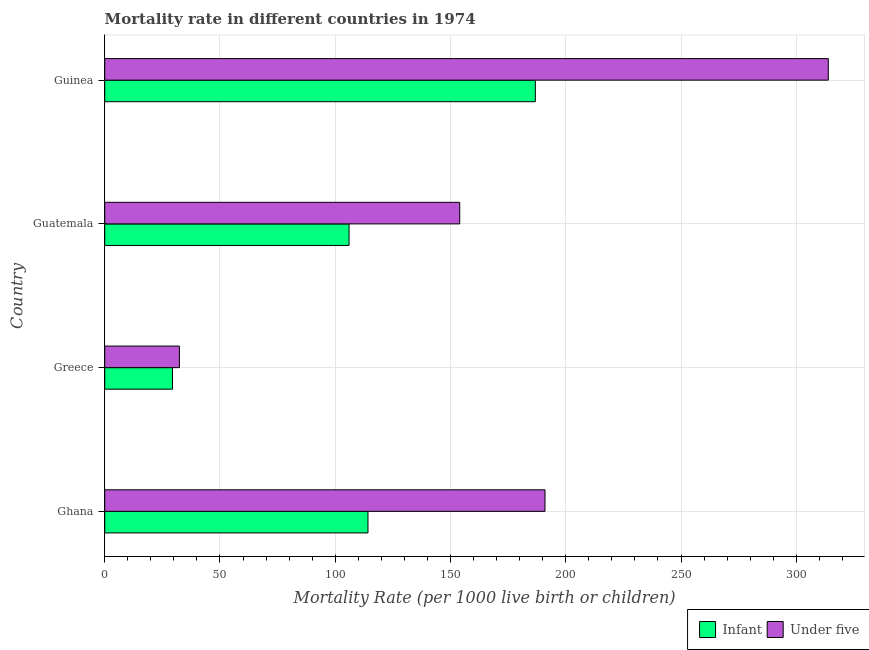Are the number of bars per tick equal to the number of legend labels?
Your answer should be very brief. Yes. How many bars are there on the 3rd tick from the top?
Offer a very short reply. 2. What is the infant mortality rate in Ghana?
Provide a succinct answer. 114.2. Across all countries, what is the maximum under-5 mortality rate?
Offer a terse response. 313.9. Across all countries, what is the minimum infant mortality rate?
Offer a very short reply. 29.4. In which country was the infant mortality rate maximum?
Provide a succinct answer. Guinea. What is the total under-5 mortality rate in the graph?
Offer a very short reply. 691.3. What is the difference between the infant mortality rate in Greece and that in Guatemala?
Your answer should be very brief. -76.6. What is the difference between the under-5 mortality rate in Ghana and the infant mortality rate in Greece?
Your answer should be compact. 161.6. What is the average under-5 mortality rate per country?
Ensure brevity in your answer.  172.82. In how many countries, is the infant mortality rate greater than 80 ?
Ensure brevity in your answer.  3. What is the ratio of the infant mortality rate in Guatemala to that in Guinea?
Keep it short and to the point. 0.57. Is the difference between the infant mortality rate in Greece and Guatemala greater than the difference between the under-5 mortality rate in Greece and Guatemala?
Your answer should be compact. Yes. What is the difference between the highest and the second highest under-5 mortality rate?
Provide a short and direct response. 122.9. What is the difference between the highest and the lowest under-5 mortality rate?
Your answer should be very brief. 281.5. In how many countries, is the under-5 mortality rate greater than the average under-5 mortality rate taken over all countries?
Offer a very short reply. 2. Is the sum of the under-5 mortality rate in Guatemala and Guinea greater than the maximum infant mortality rate across all countries?
Give a very brief answer. Yes. What does the 1st bar from the top in Guatemala represents?
Ensure brevity in your answer.  Under five. What does the 2nd bar from the bottom in Ghana represents?
Ensure brevity in your answer.  Under five. How many countries are there in the graph?
Offer a terse response. 4. Does the graph contain any zero values?
Keep it short and to the point. No. How many legend labels are there?
Your response must be concise. 2. How are the legend labels stacked?
Ensure brevity in your answer.  Horizontal. What is the title of the graph?
Your answer should be very brief. Mortality rate in different countries in 1974. What is the label or title of the X-axis?
Your response must be concise. Mortality Rate (per 1000 live birth or children). What is the label or title of the Y-axis?
Offer a terse response. Country. What is the Mortality Rate (per 1000 live birth or children) of Infant in Ghana?
Your response must be concise. 114.2. What is the Mortality Rate (per 1000 live birth or children) in Under five in Ghana?
Give a very brief answer. 191. What is the Mortality Rate (per 1000 live birth or children) of Infant in Greece?
Your answer should be very brief. 29.4. What is the Mortality Rate (per 1000 live birth or children) in Under five in Greece?
Ensure brevity in your answer.  32.4. What is the Mortality Rate (per 1000 live birth or children) of Infant in Guatemala?
Offer a very short reply. 106. What is the Mortality Rate (per 1000 live birth or children) of Under five in Guatemala?
Offer a very short reply. 154. What is the Mortality Rate (per 1000 live birth or children) in Infant in Guinea?
Your answer should be compact. 186.8. What is the Mortality Rate (per 1000 live birth or children) of Under five in Guinea?
Provide a succinct answer. 313.9. Across all countries, what is the maximum Mortality Rate (per 1000 live birth or children) of Infant?
Give a very brief answer. 186.8. Across all countries, what is the maximum Mortality Rate (per 1000 live birth or children) of Under five?
Give a very brief answer. 313.9. Across all countries, what is the minimum Mortality Rate (per 1000 live birth or children) of Infant?
Your response must be concise. 29.4. Across all countries, what is the minimum Mortality Rate (per 1000 live birth or children) of Under five?
Provide a succinct answer. 32.4. What is the total Mortality Rate (per 1000 live birth or children) in Infant in the graph?
Your response must be concise. 436.4. What is the total Mortality Rate (per 1000 live birth or children) in Under five in the graph?
Make the answer very short. 691.3. What is the difference between the Mortality Rate (per 1000 live birth or children) of Infant in Ghana and that in Greece?
Provide a short and direct response. 84.8. What is the difference between the Mortality Rate (per 1000 live birth or children) of Under five in Ghana and that in Greece?
Make the answer very short. 158.6. What is the difference between the Mortality Rate (per 1000 live birth or children) of Infant in Ghana and that in Guatemala?
Offer a very short reply. 8.2. What is the difference between the Mortality Rate (per 1000 live birth or children) in Under five in Ghana and that in Guatemala?
Offer a very short reply. 37. What is the difference between the Mortality Rate (per 1000 live birth or children) of Infant in Ghana and that in Guinea?
Offer a terse response. -72.6. What is the difference between the Mortality Rate (per 1000 live birth or children) of Under five in Ghana and that in Guinea?
Offer a very short reply. -122.9. What is the difference between the Mortality Rate (per 1000 live birth or children) of Infant in Greece and that in Guatemala?
Your answer should be very brief. -76.6. What is the difference between the Mortality Rate (per 1000 live birth or children) of Under five in Greece and that in Guatemala?
Keep it short and to the point. -121.6. What is the difference between the Mortality Rate (per 1000 live birth or children) of Infant in Greece and that in Guinea?
Offer a terse response. -157.4. What is the difference between the Mortality Rate (per 1000 live birth or children) in Under five in Greece and that in Guinea?
Your answer should be very brief. -281.5. What is the difference between the Mortality Rate (per 1000 live birth or children) of Infant in Guatemala and that in Guinea?
Offer a terse response. -80.8. What is the difference between the Mortality Rate (per 1000 live birth or children) in Under five in Guatemala and that in Guinea?
Give a very brief answer. -159.9. What is the difference between the Mortality Rate (per 1000 live birth or children) of Infant in Ghana and the Mortality Rate (per 1000 live birth or children) of Under five in Greece?
Your answer should be very brief. 81.8. What is the difference between the Mortality Rate (per 1000 live birth or children) in Infant in Ghana and the Mortality Rate (per 1000 live birth or children) in Under five in Guatemala?
Give a very brief answer. -39.8. What is the difference between the Mortality Rate (per 1000 live birth or children) of Infant in Ghana and the Mortality Rate (per 1000 live birth or children) of Under five in Guinea?
Give a very brief answer. -199.7. What is the difference between the Mortality Rate (per 1000 live birth or children) of Infant in Greece and the Mortality Rate (per 1000 live birth or children) of Under five in Guatemala?
Give a very brief answer. -124.6. What is the difference between the Mortality Rate (per 1000 live birth or children) in Infant in Greece and the Mortality Rate (per 1000 live birth or children) in Under five in Guinea?
Your answer should be very brief. -284.5. What is the difference between the Mortality Rate (per 1000 live birth or children) in Infant in Guatemala and the Mortality Rate (per 1000 live birth or children) in Under five in Guinea?
Your answer should be compact. -207.9. What is the average Mortality Rate (per 1000 live birth or children) of Infant per country?
Your answer should be very brief. 109.1. What is the average Mortality Rate (per 1000 live birth or children) of Under five per country?
Your answer should be very brief. 172.82. What is the difference between the Mortality Rate (per 1000 live birth or children) in Infant and Mortality Rate (per 1000 live birth or children) in Under five in Ghana?
Provide a short and direct response. -76.8. What is the difference between the Mortality Rate (per 1000 live birth or children) in Infant and Mortality Rate (per 1000 live birth or children) in Under five in Guatemala?
Your answer should be very brief. -48. What is the difference between the Mortality Rate (per 1000 live birth or children) in Infant and Mortality Rate (per 1000 live birth or children) in Under five in Guinea?
Keep it short and to the point. -127.1. What is the ratio of the Mortality Rate (per 1000 live birth or children) in Infant in Ghana to that in Greece?
Offer a very short reply. 3.88. What is the ratio of the Mortality Rate (per 1000 live birth or children) of Under five in Ghana to that in Greece?
Offer a terse response. 5.9. What is the ratio of the Mortality Rate (per 1000 live birth or children) of Infant in Ghana to that in Guatemala?
Your answer should be compact. 1.08. What is the ratio of the Mortality Rate (per 1000 live birth or children) in Under five in Ghana to that in Guatemala?
Provide a short and direct response. 1.24. What is the ratio of the Mortality Rate (per 1000 live birth or children) in Infant in Ghana to that in Guinea?
Offer a terse response. 0.61. What is the ratio of the Mortality Rate (per 1000 live birth or children) in Under five in Ghana to that in Guinea?
Give a very brief answer. 0.61. What is the ratio of the Mortality Rate (per 1000 live birth or children) in Infant in Greece to that in Guatemala?
Your answer should be very brief. 0.28. What is the ratio of the Mortality Rate (per 1000 live birth or children) in Under five in Greece to that in Guatemala?
Your answer should be very brief. 0.21. What is the ratio of the Mortality Rate (per 1000 live birth or children) in Infant in Greece to that in Guinea?
Your answer should be very brief. 0.16. What is the ratio of the Mortality Rate (per 1000 live birth or children) in Under five in Greece to that in Guinea?
Give a very brief answer. 0.1. What is the ratio of the Mortality Rate (per 1000 live birth or children) of Infant in Guatemala to that in Guinea?
Your response must be concise. 0.57. What is the ratio of the Mortality Rate (per 1000 live birth or children) in Under five in Guatemala to that in Guinea?
Your response must be concise. 0.49. What is the difference between the highest and the second highest Mortality Rate (per 1000 live birth or children) in Infant?
Provide a short and direct response. 72.6. What is the difference between the highest and the second highest Mortality Rate (per 1000 live birth or children) in Under five?
Provide a short and direct response. 122.9. What is the difference between the highest and the lowest Mortality Rate (per 1000 live birth or children) of Infant?
Make the answer very short. 157.4. What is the difference between the highest and the lowest Mortality Rate (per 1000 live birth or children) of Under five?
Ensure brevity in your answer.  281.5. 